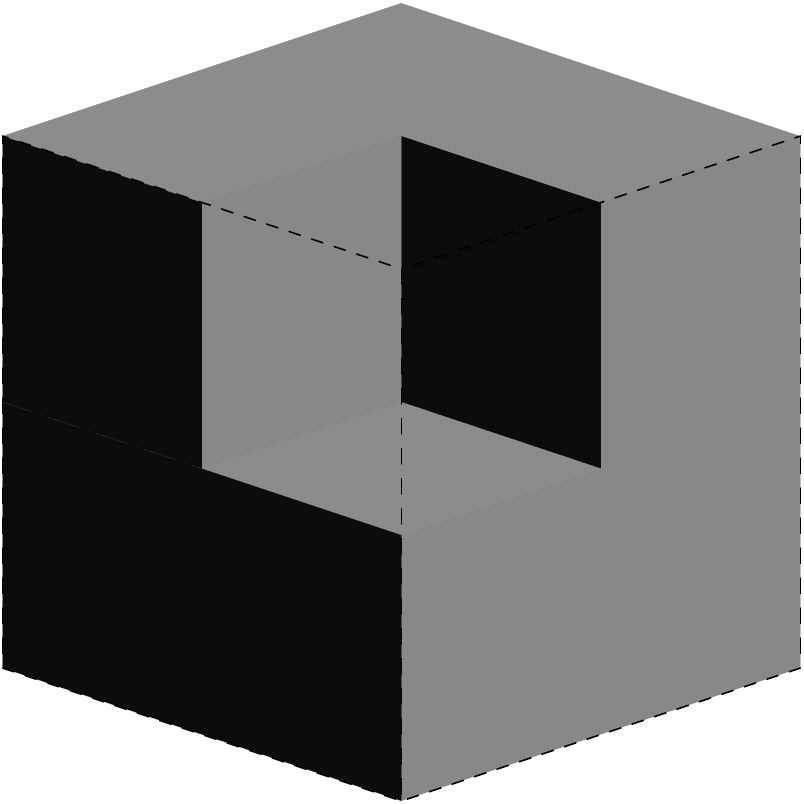You're helping a friend move and notice a peculiar stack of boxes. The image shows three views of this stack: front, top, and side. How many boxes are there in total? Let's approach this step-by-step:

1. Front view: We can see 4 boxes arranged in a 2x2 grid.
2. Top view: We can see 6 boxes arranged in a 2x3 grid.
3. Side view: We can see 4 boxes arranged in a 2x2 grid.

To determine the total number of boxes:

1. The front view tells us there are at least 4 boxes.
2. The top view shows 3 boxes deep, but we only see 2 from the front. This means there must be a hidden box behind one of the front boxes.
3. We can confirm this with the side view, which shows 2 boxes deep.

Therefore, the structure consists of:
- 4 boxes visible from the front
- 1 additional box hidden behind

The total number of boxes is thus $4 + 1 = 5$.
Answer: 5 boxes 